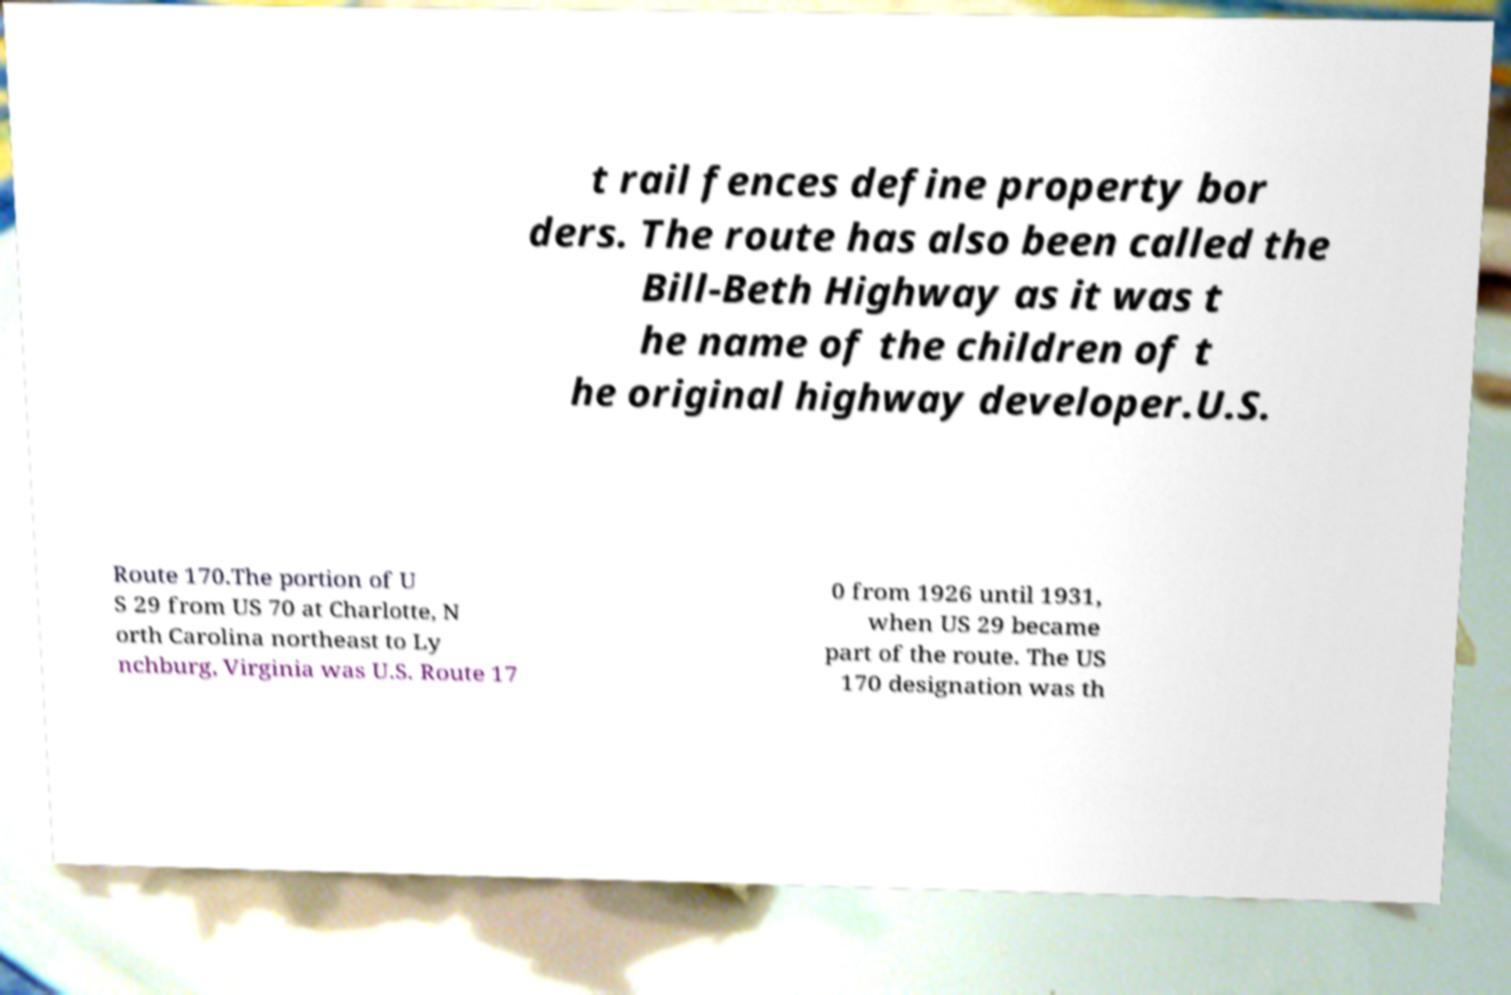Please read and relay the text visible in this image. What does it say? t rail fences define property bor ders. The route has also been called the Bill-Beth Highway as it was t he name of the children of t he original highway developer.U.S. Route 170.The portion of U S 29 from US 70 at Charlotte, N orth Carolina northeast to Ly nchburg, Virginia was U.S. Route 17 0 from 1926 until 1931, when US 29 became part of the route. The US 170 designation was th 